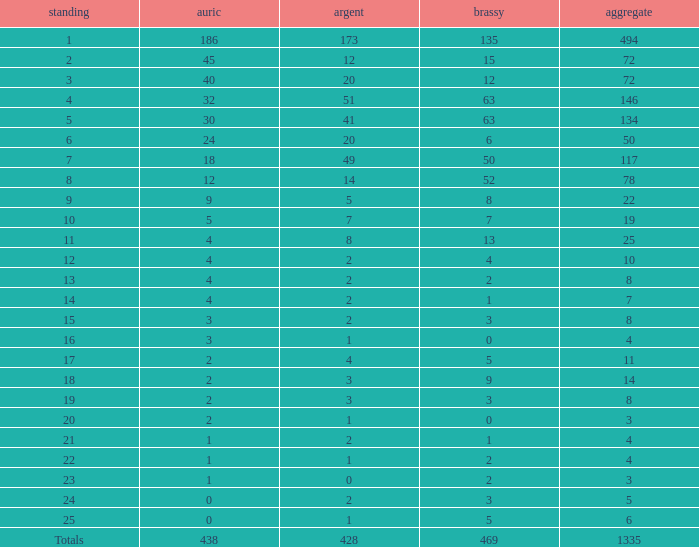What is the total amount of gold medals when there were more than 20 silvers and there were 135 bronze medals? 1.0. 